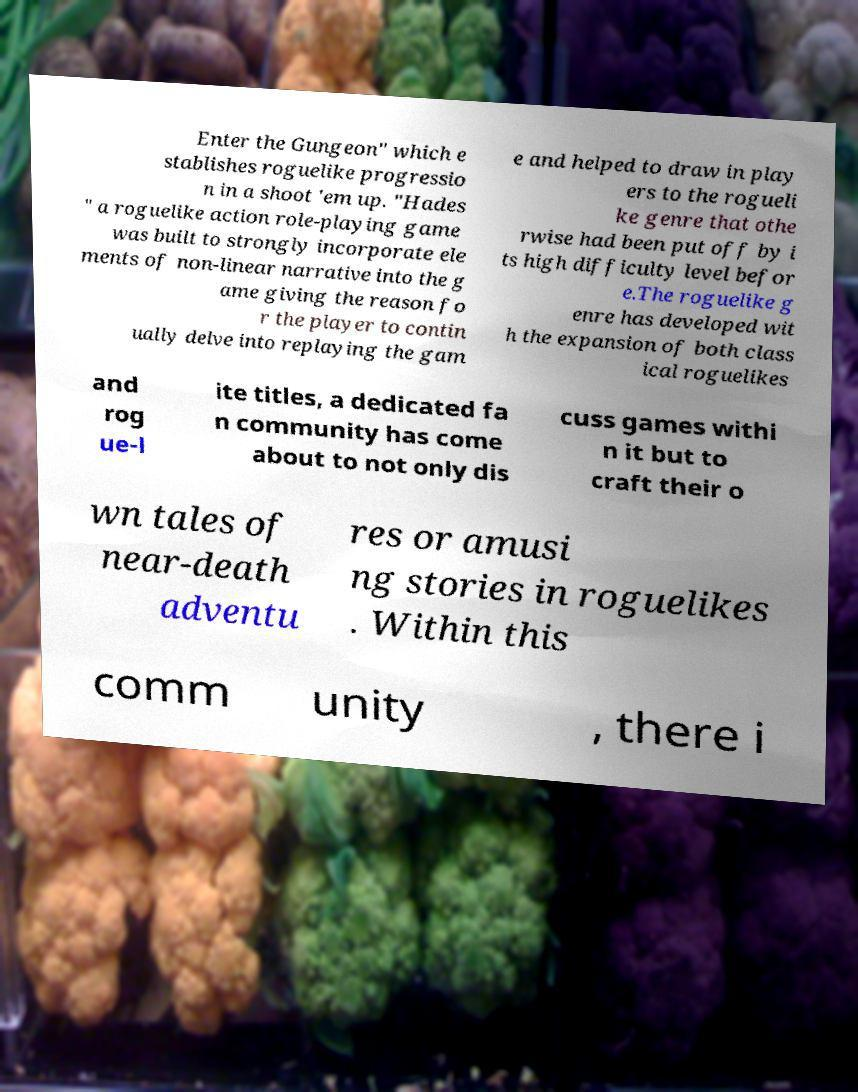Could you assist in decoding the text presented in this image and type it out clearly? Enter the Gungeon" which e stablishes roguelike progressio n in a shoot 'em up. "Hades " a roguelike action role-playing game was built to strongly incorporate ele ments of non-linear narrative into the g ame giving the reason fo r the player to contin ually delve into replaying the gam e and helped to draw in play ers to the rogueli ke genre that othe rwise had been put off by i ts high difficulty level befor e.The roguelike g enre has developed wit h the expansion of both class ical roguelikes and rog ue-l ite titles, a dedicated fa n community has come about to not only dis cuss games withi n it but to craft their o wn tales of near-death adventu res or amusi ng stories in roguelikes . Within this comm unity , there i 